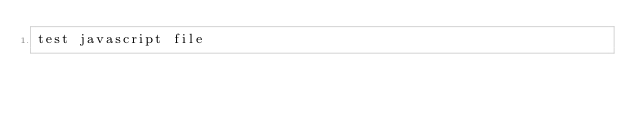<code> <loc_0><loc_0><loc_500><loc_500><_JavaScript_>test javascript file</code> 